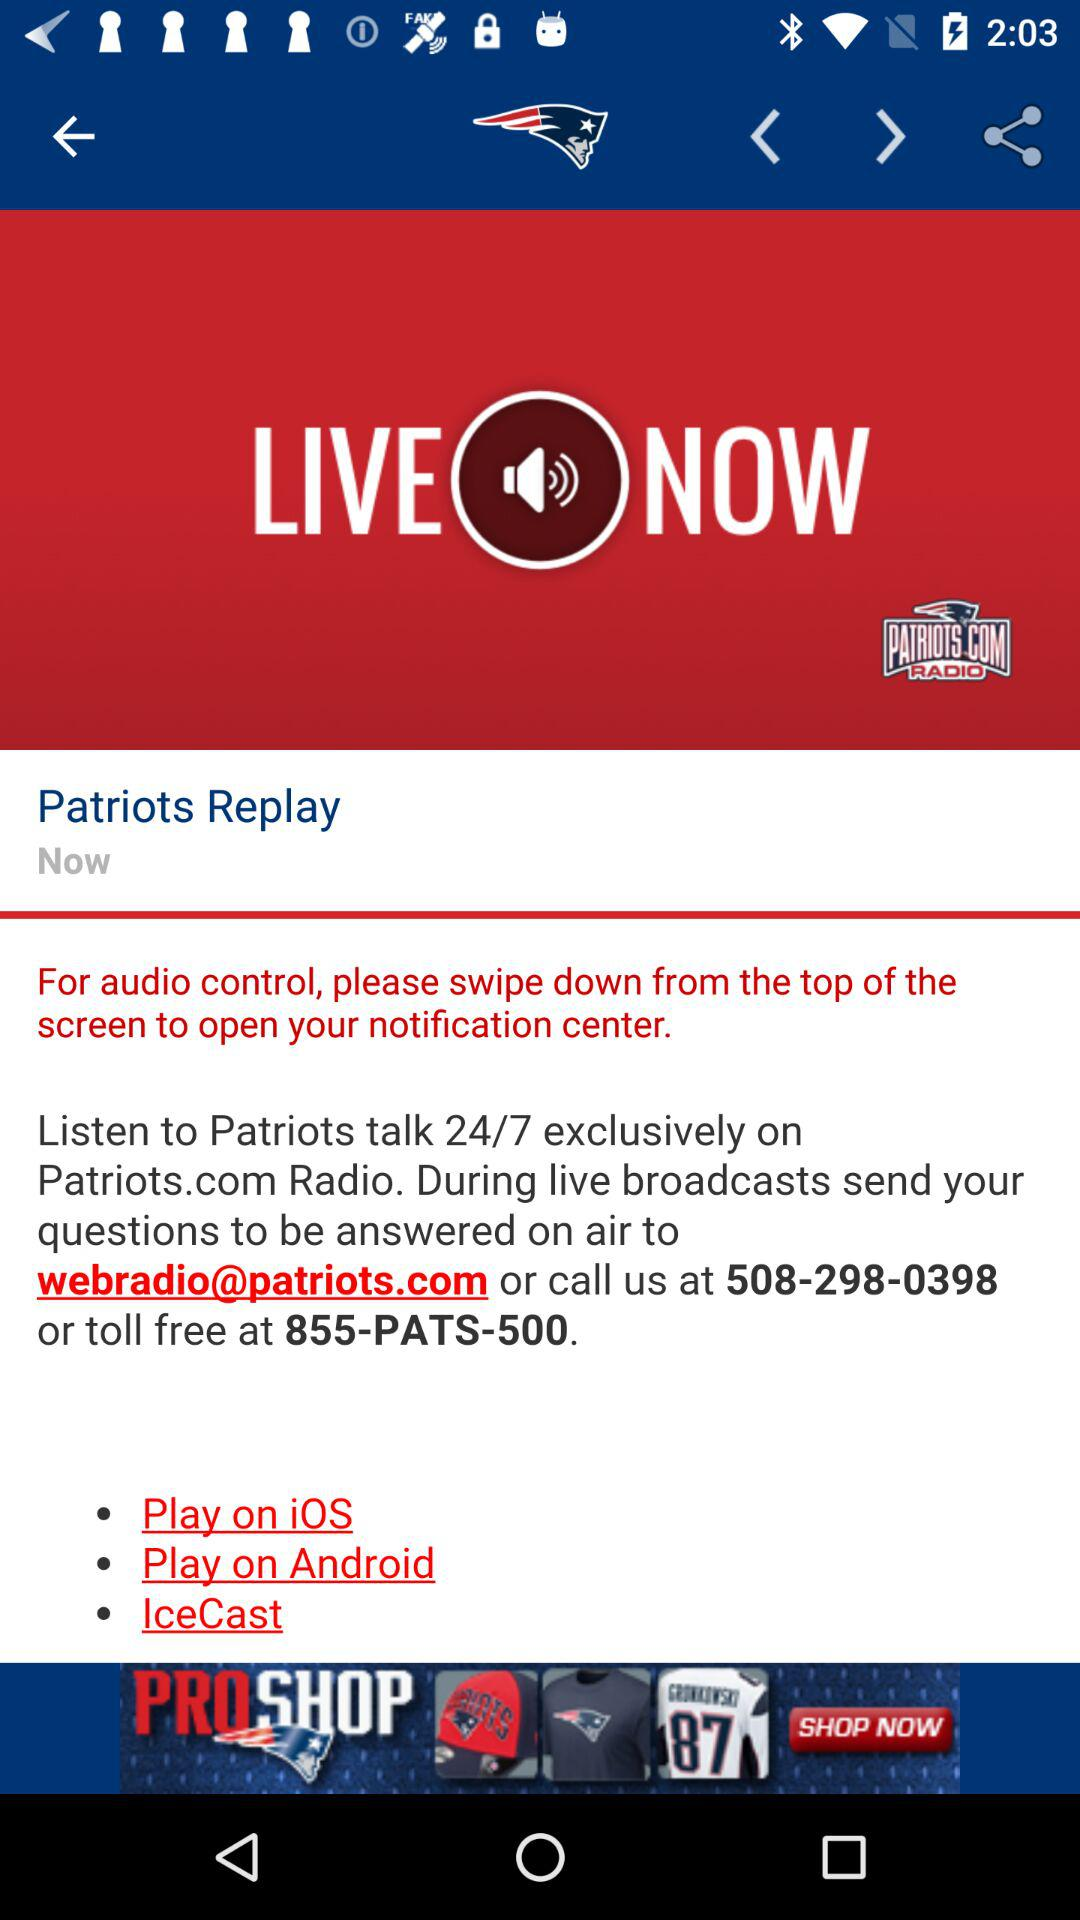What is the email address? The email address is webradio@patriots.com. 